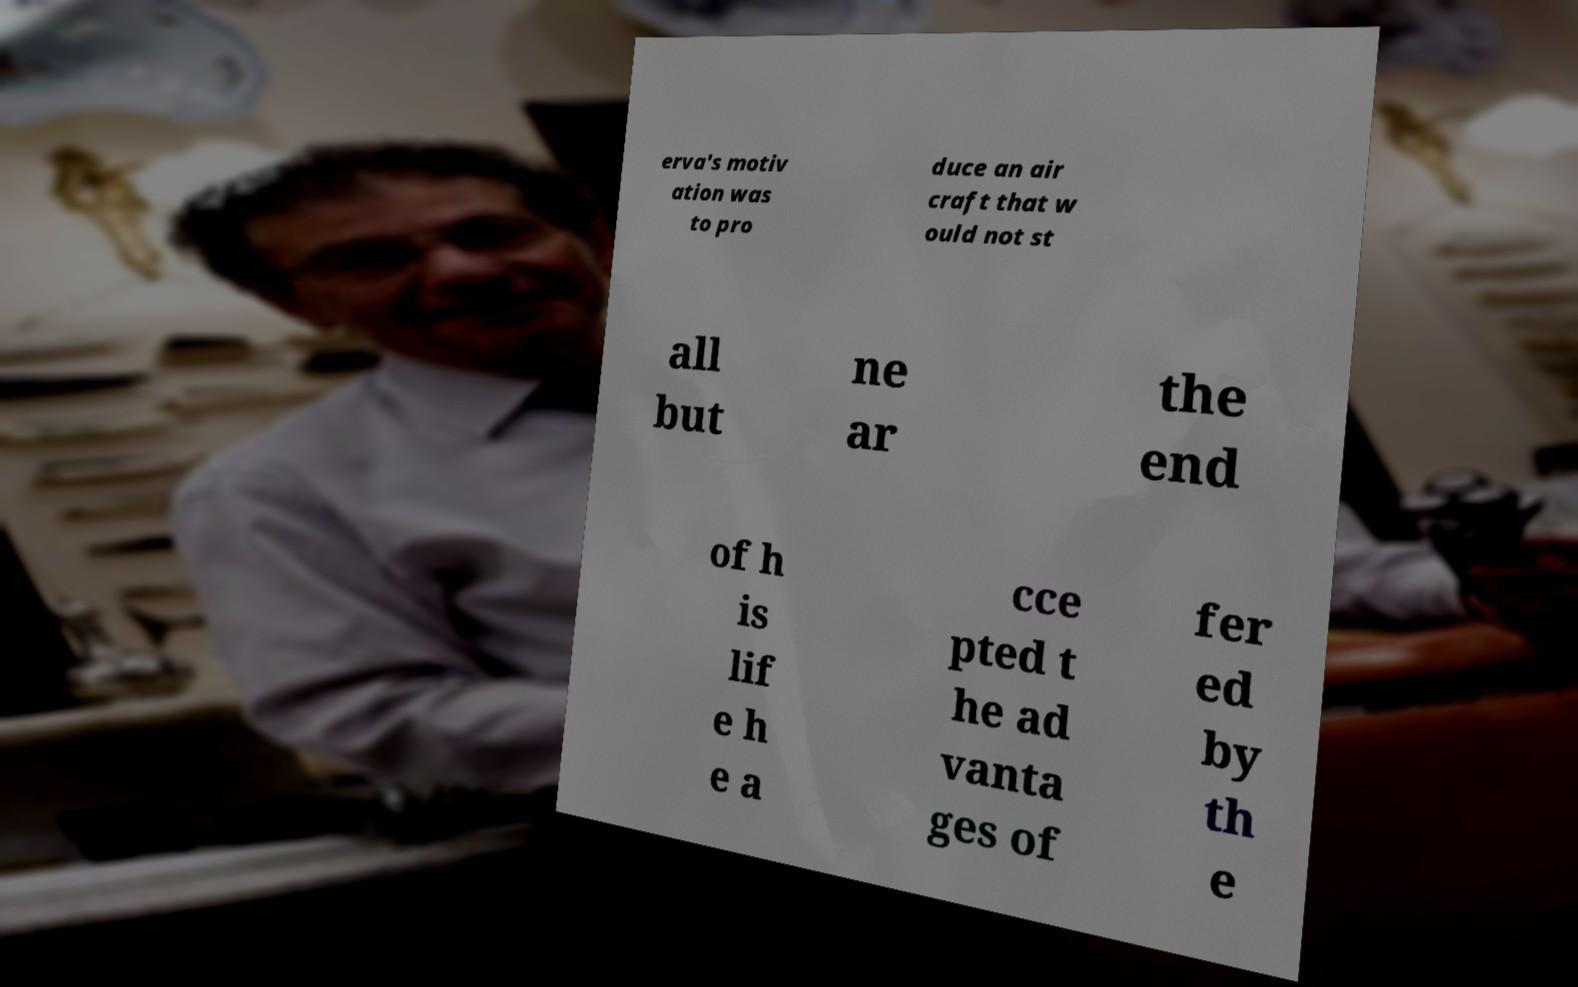Could you assist in decoding the text presented in this image and type it out clearly? erva's motiv ation was to pro duce an air craft that w ould not st all but ne ar the end of h is lif e h e a cce pted t he ad vanta ges of fer ed by th e 